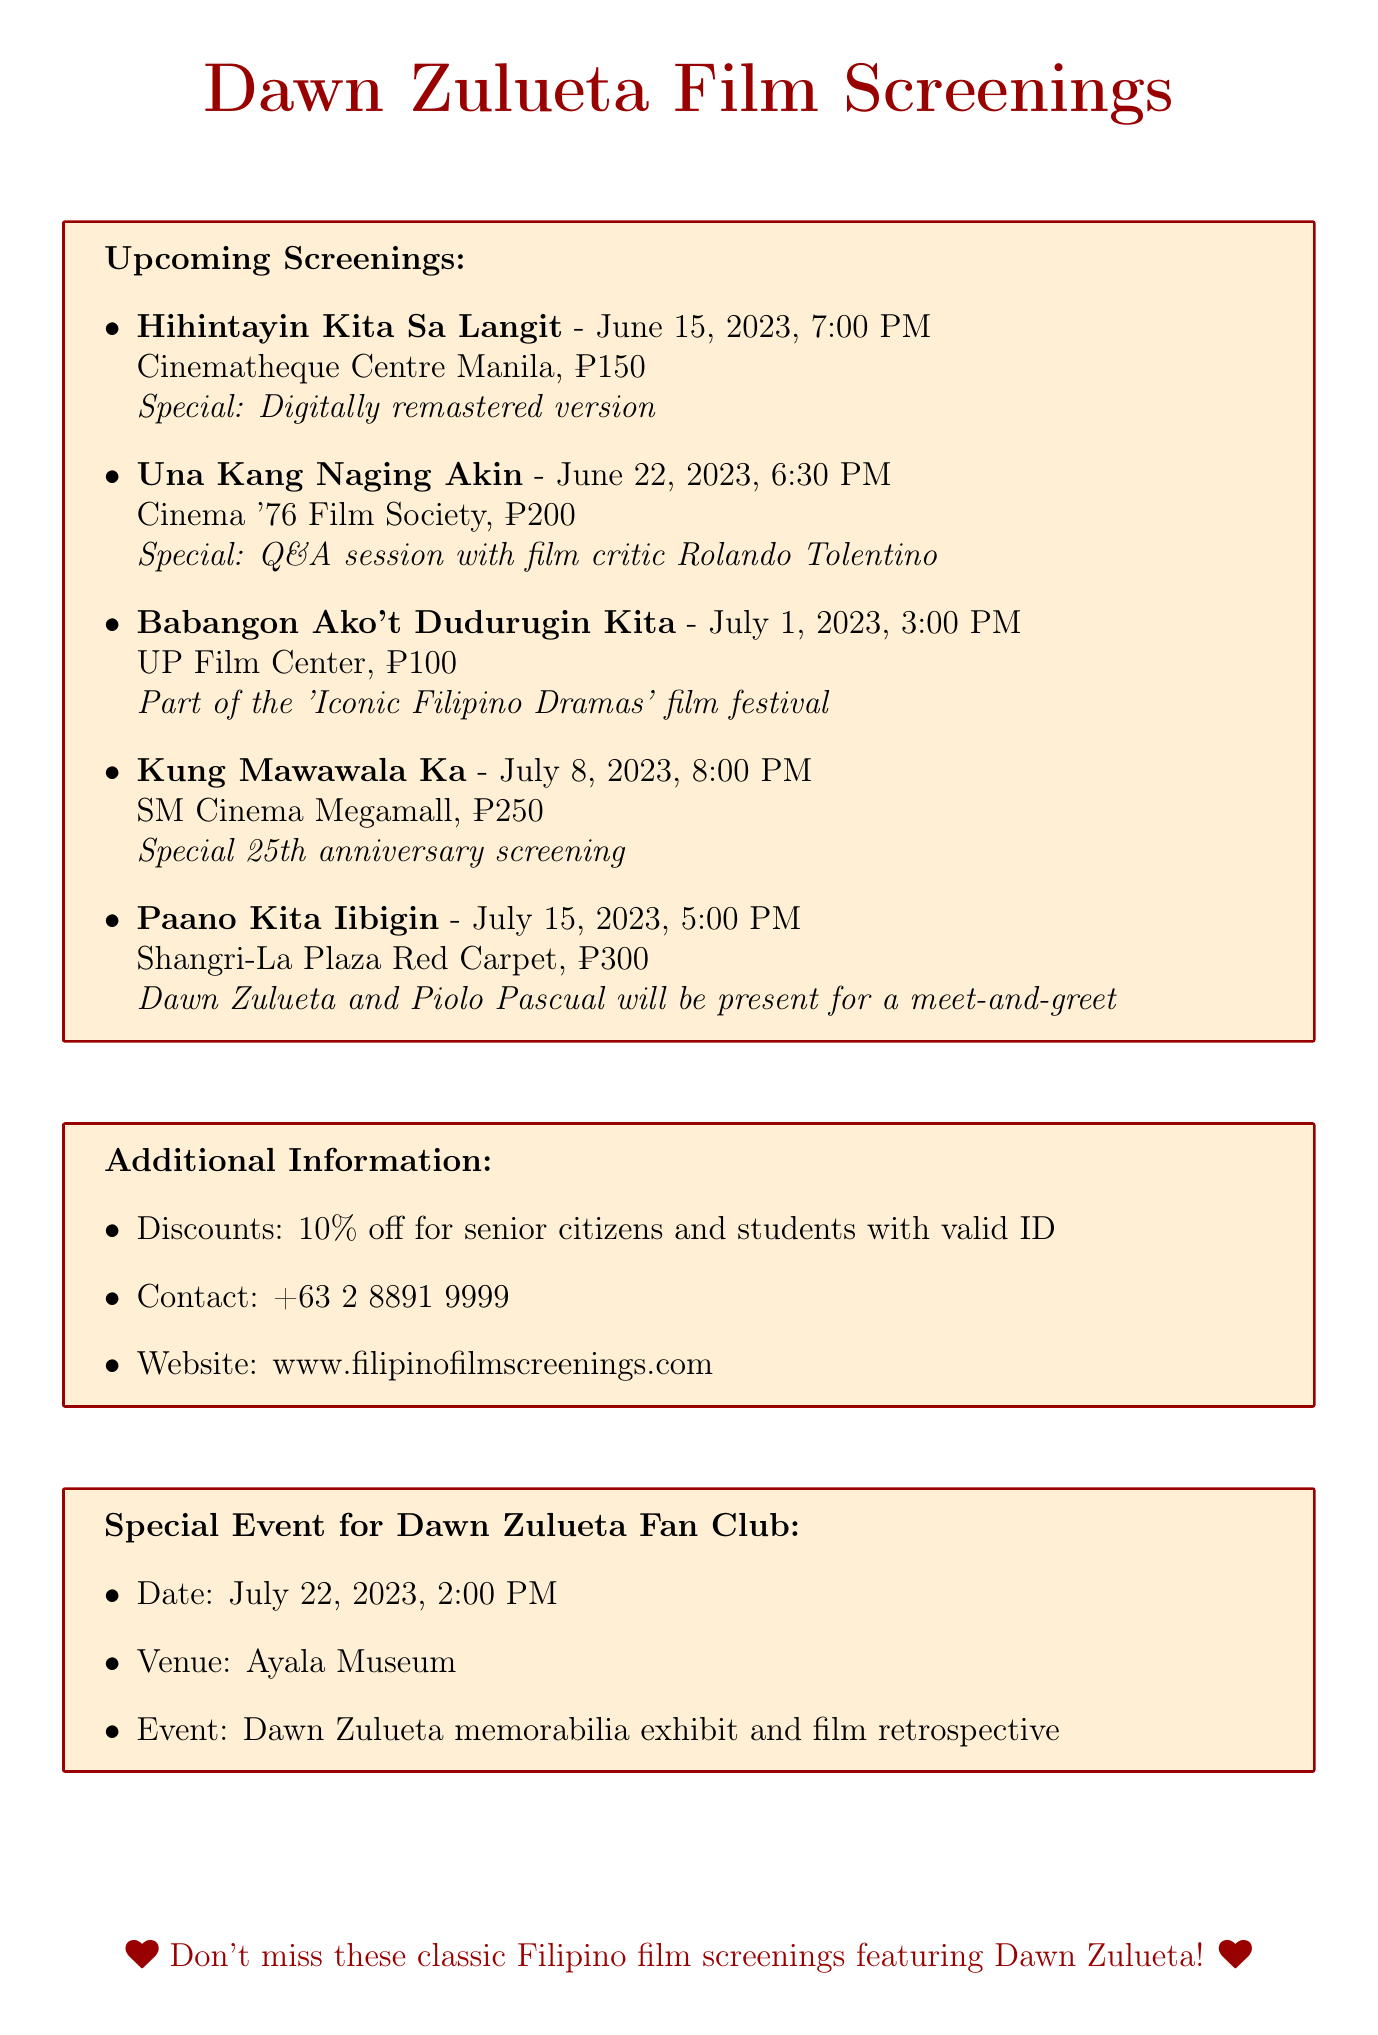What is the title of the film screening on June 15, 2023? The title of the film screening is the first item listed for that date in the document.
Answer: Hihintayin Kita Sa Langit What is the ticket price for "Paano Kita Iibigin"? The ticket price is listed next to the film title in the document.
Answer: ₱300 Which theater will host the screening of "Kung Mawawala Ka"? The theater is specified directly beside the film title in the document.
Answer: SM Cinema Megamall What special event will occur after the screening of "Una Kang Naging Akin"? The special event is mentioned in the description of the film screening.
Answer: Q&A session with film critic Rolando Tolentino How much discount do senior citizens receive? The discount information is explicitly noted in the additional information section of the document.
Answer: 10% off What is the date of the Dawn Zulueta memorabilia exhibit? The date is stated in the special event section specifically for the fan club.
Answer: July 22, 2023 What time does the screening of "Babangon Ako't Dudurugin Kita" start? The time is listed directly next to the film title in the document.
Answer: 3:00 PM What special note is provided for "Kung Mawawala Ka"? The special note is included in the details of the film screening in the document.
Answer: Special 25th anniversary screening 